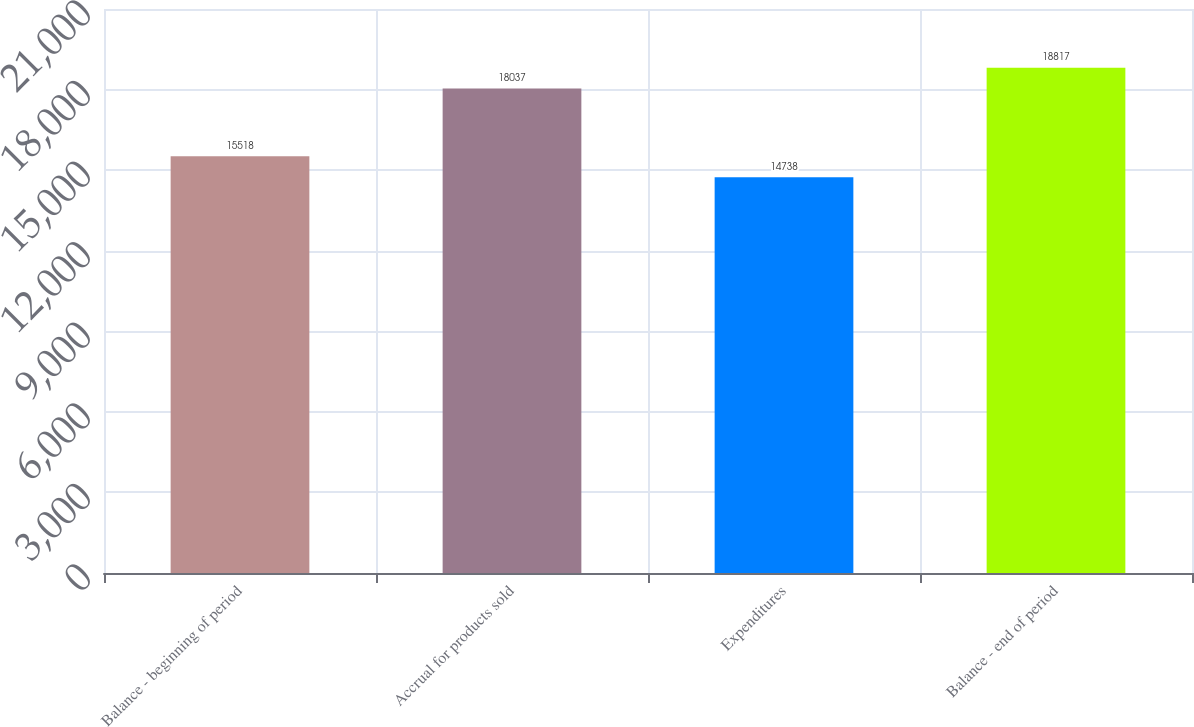<chart> <loc_0><loc_0><loc_500><loc_500><bar_chart><fcel>Balance - beginning of period<fcel>Accrual for products sold<fcel>Expenditures<fcel>Balance - end of period<nl><fcel>15518<fcel>18037<fcel>14738<fcel>18817<nl></chart> 